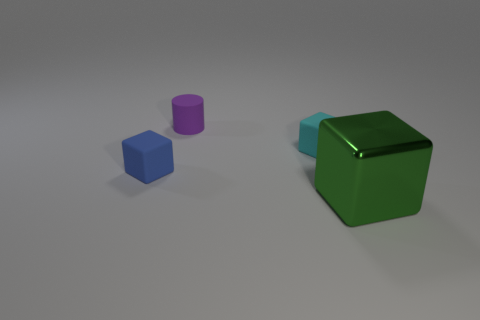Subtract all large shiny cubes. How many cubes are left? 2 Subtract 1 blocks. How many blocks are left? 2 Add 3 purple cubes. How many objects exist? 7 Subtract all cubes. How many objects are left? 1 Subtract all brown blocks. Subtract all cyan cylinders. How many blocks are left? 3 Subtract all small cyan blocks. Subtract all blue rubber cubes. How many objects are left? 2 Add 3 tiny matte things. How many tiny matte things are left? 6 Add 4 large brown rubber balls. How many large brown rubber balls exist? 4 Subtract 0 yellow blocks. How many objects are left? 4 